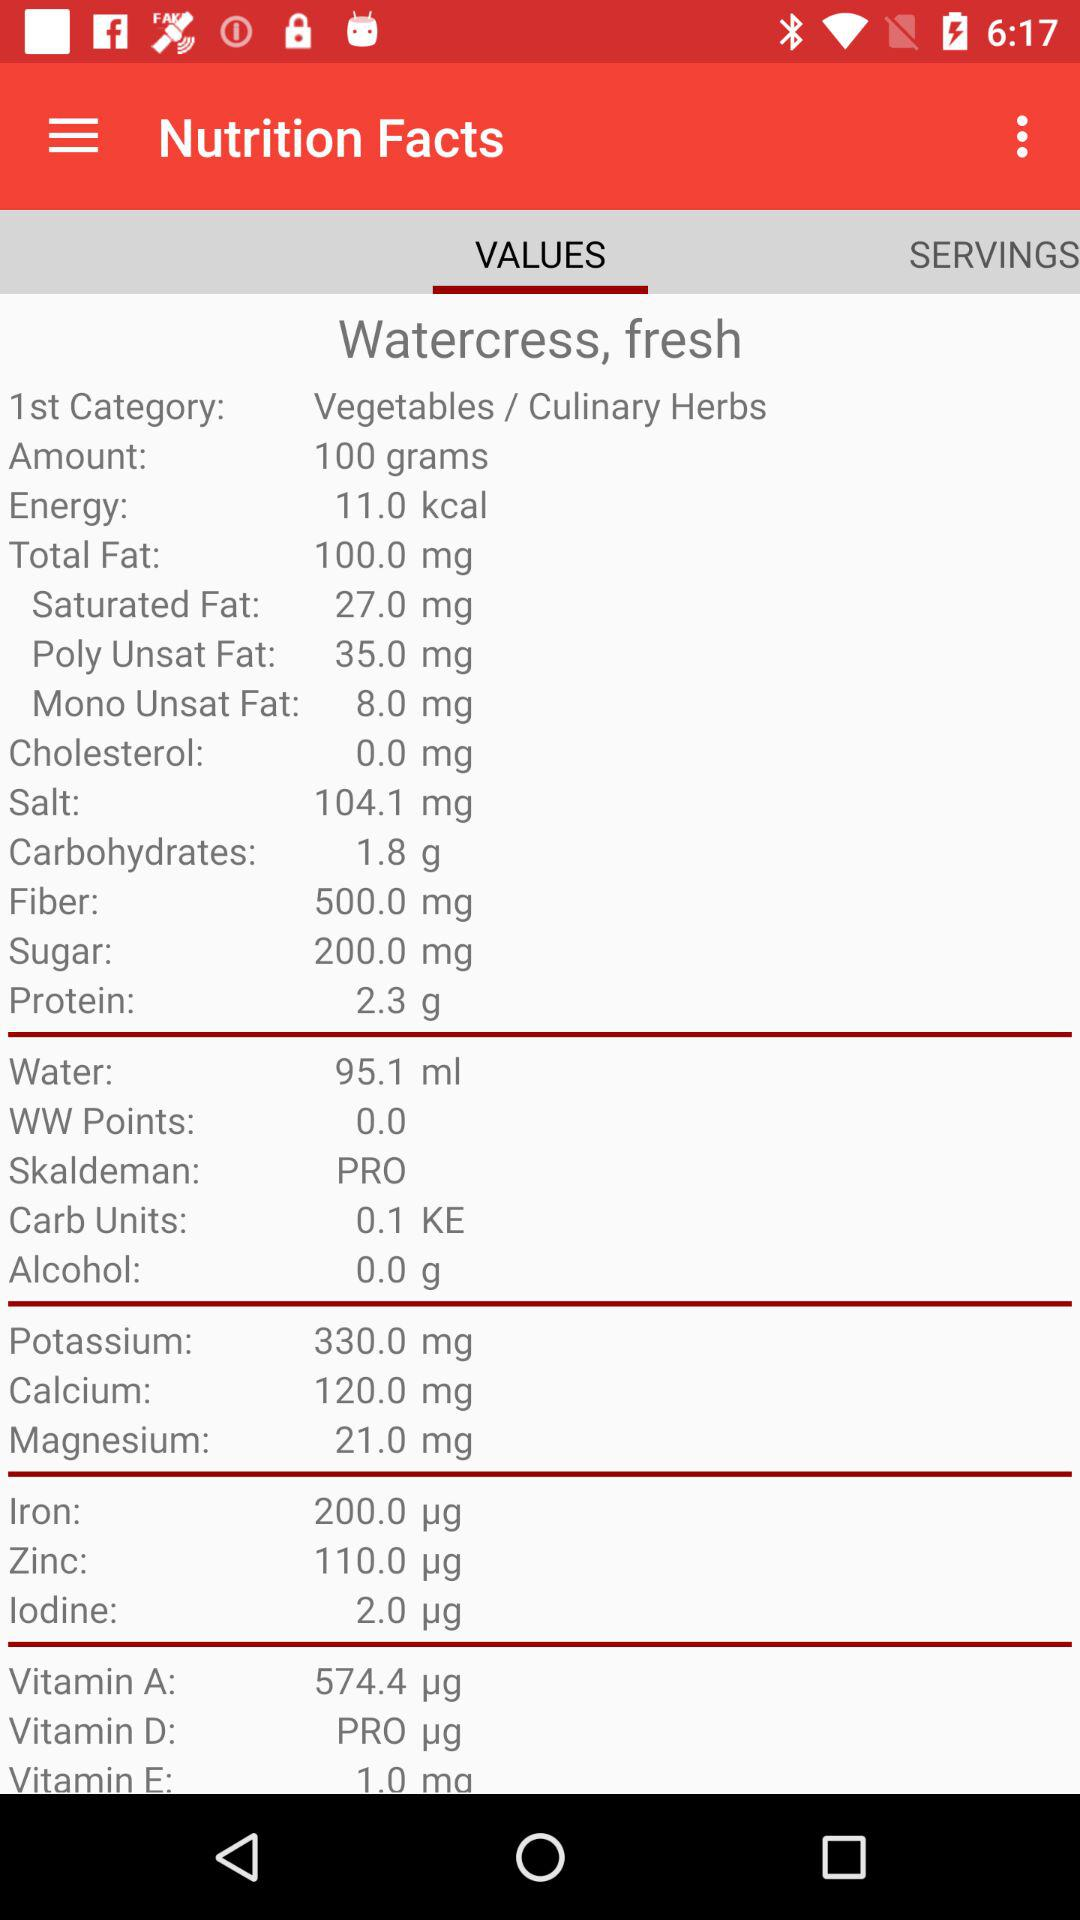Which tab is selected? The selected tab is "VALUES". 